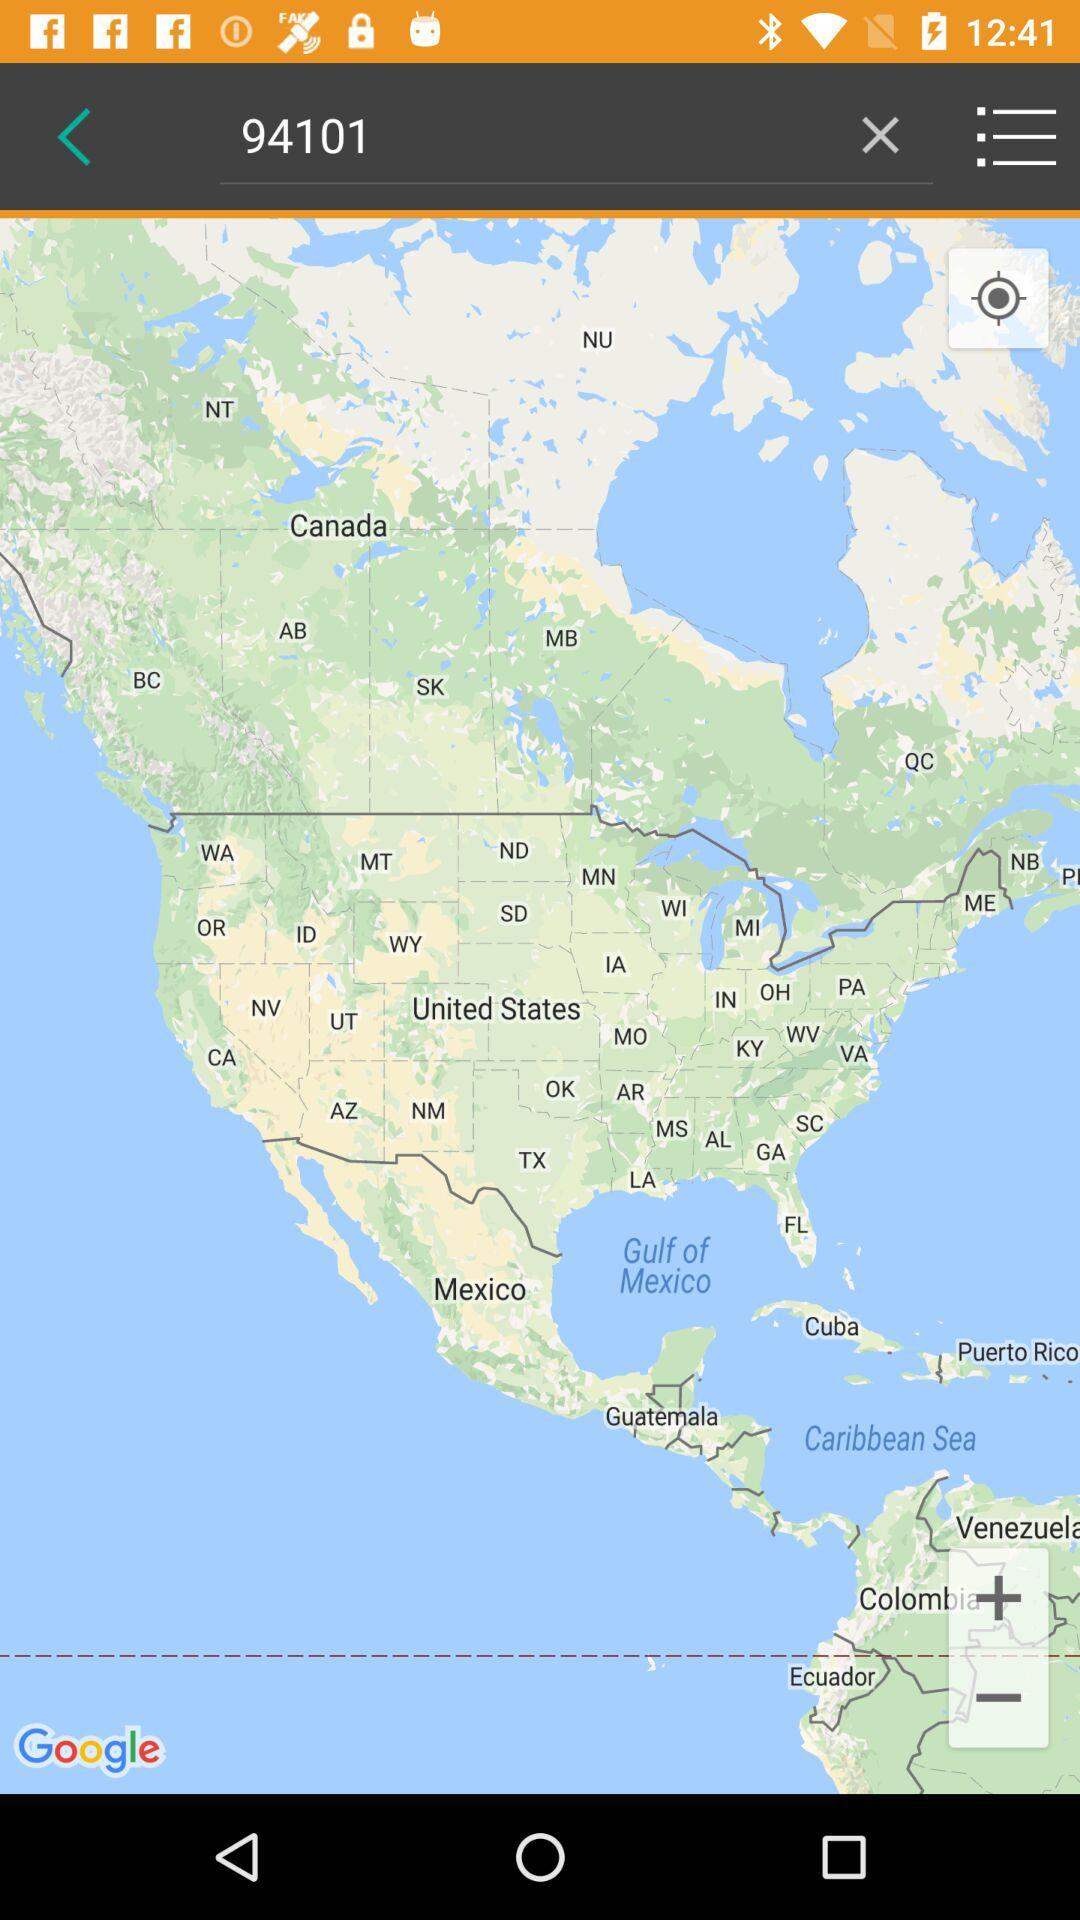What code is searched in the search bar? The code being searched in the search bar is 94101. 